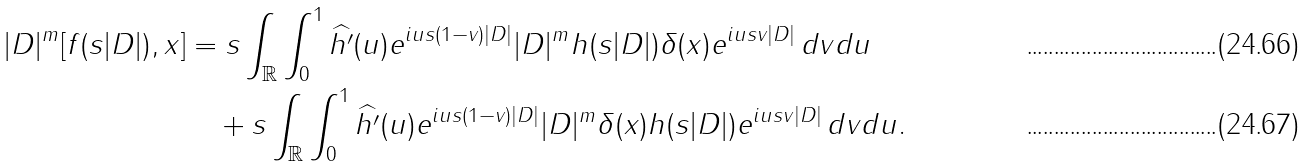<formula> <loc_0><loc_0><loc_500><loc_500>| D | ^ { m } [ f ( s | D | ) , x ] & = s \int _ { \mathbb { R } } \int _ { 0 } ^ { 1 } \widehat { h ^ { \prime } } ( u ) e ^ { i u s ( 1 - v ) | D | } | D | ^ { m } h ( s | D | ) \delta ( x ) e ^ { i u s v | D | } \, d v d u \\ & \quad + s \int _ { \mathbb { R } } \int _ { 0 } ^ { 1 } \widehat { h ^ { \prime } } ( u ) e ^ { i u s ( 1 - v ) | D | } | D | ^ { m } \delta ( x ) h ( s | D | ) e ^ { i u s v | D | } \, d v d u .</formula> 